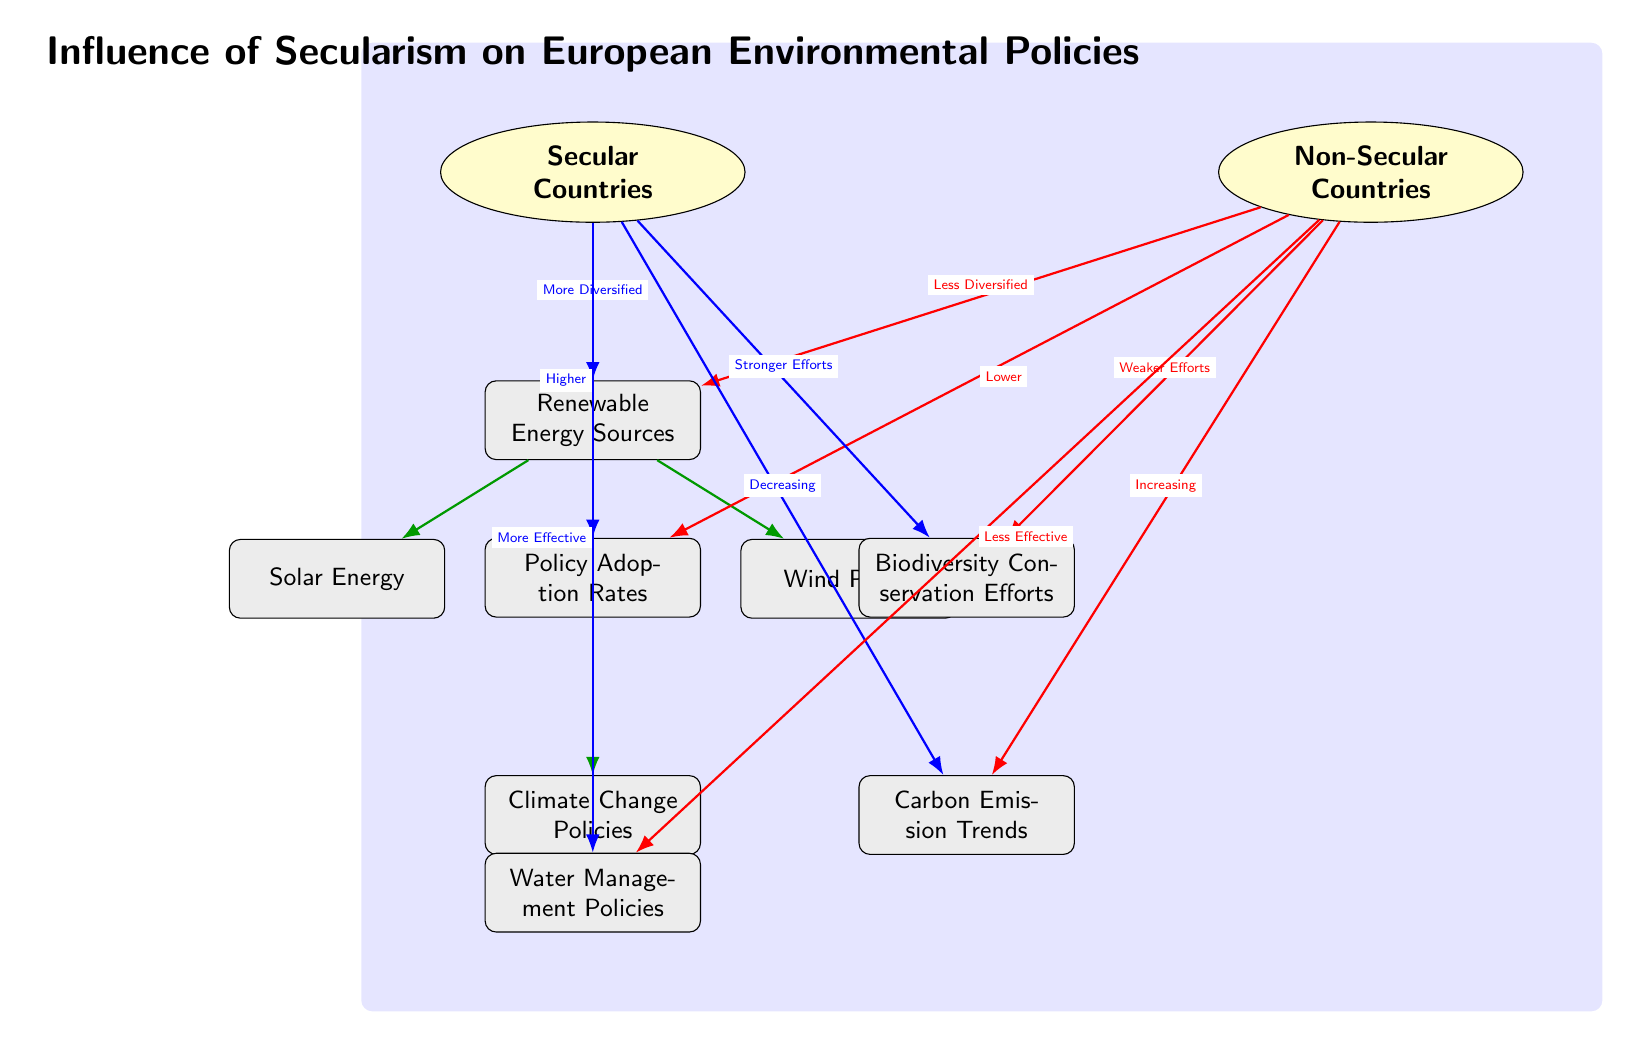What type of countries exhibit more diversified renewable energy sources? The diagram indicates that secular countries have a relationship labeled "More Diversified" leading from them to the node representing renewable energy sources. Thus, it specifies secular countries as having diversified renewable energy sources.
Answer: Secular Countries How do secular countries perform in terms of policy adoption rates compared to non-secular countries? An edge labeled "Higher" flows from secular countries to the policy adoption rates node, while a "Lower" edge flows from non-secular countries. This indicates that secular countries adopt policies at higher rates than non-secular countries.
Answer: Higher What trend is associated with carbon emissions in secular countries? The diagram shows an edge leading from secular countries to the carbon emissions trends node with the label "Decreasing." This means that carbon emissions in secular countries are associated with a declining trend.
Answer: Decreasing Which renewable energy sources are indicated in the diagram? The renewable energy sources node has two edges leading to solar energy and wind power. Therefore, these are the specified renewable energy sources.
Answer: Solar Energy, Wind Power How would you compare biodiversity conservation efforts between secular and non-secular countries? The diagram depicts two edges: one from secular countries labeled "Stronger Efforts" leading to biodiversity conservation and another from non-secular countries labeled "Weaker Efforts." This shows that secular countries exhibit stronger conservation efforts compared to non-secular nations.
Answer: Stronger Efforts What implications do secular nations have on water resource management policies? An edge labeled "More Effective" flows from secular countries to water management policies, while a corresponding edge from non-secular countries is labeled "Less Effective." This signifies that secular countries are associated with more effective water management policies.
Answer: More Effective 